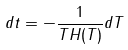Convert formula to latex. <formula><loc_0><loc_0><loc_500><loc_500>d t = - \frac { 1 } { T H ( T ) } d T</formula> 